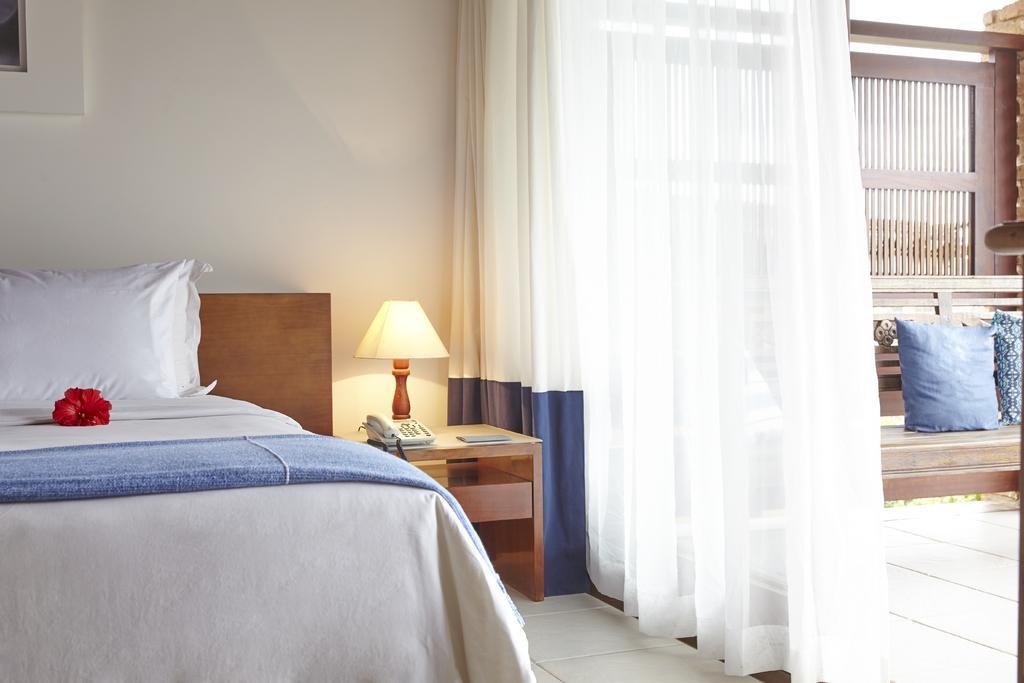Please provide a concise description of this image. There is a white bed which has a red flower on it and there is a table which has a telephone and a lamp on it and there is a white curtain beside the table. 